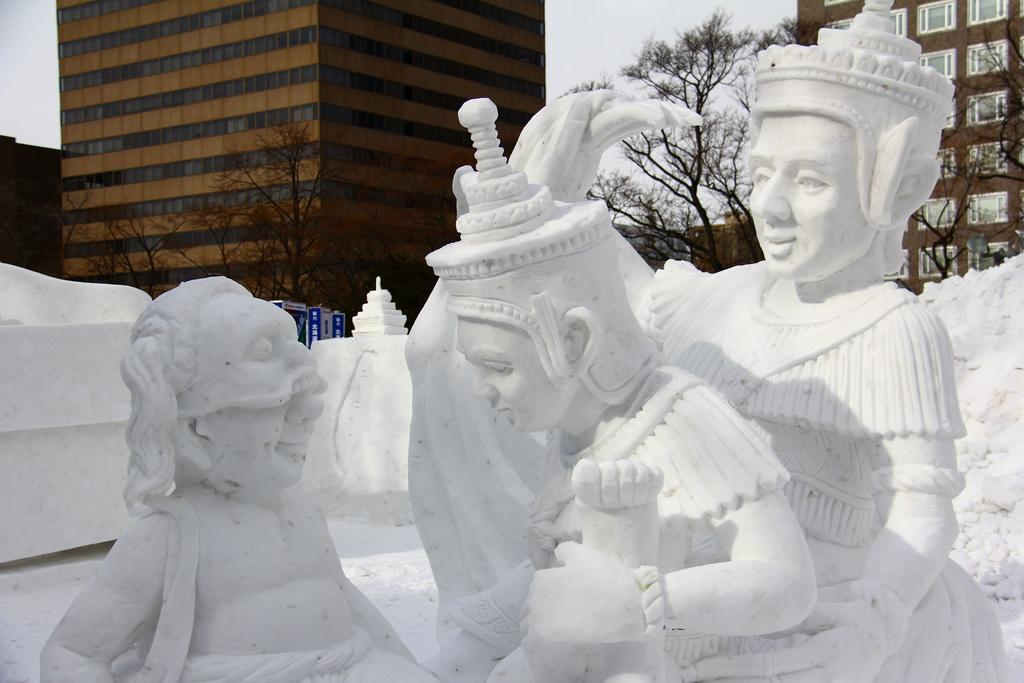What can be seen in the foreground of the image? There are sculptures in the foreground of the image. What is visible in the background of the image? There are buildings and trees in the background of the image. What is attached to the pole in the image? There are boards on a pole in the image. What is visible at the top of the image? The sky is visible at the top of the image. Can you tell me how many daughters are depicted in the scene? There is no scene or daughter present in the image; it features sculptures, buildings, trees, boards on a pole, and the sky. What type of cave can be seen in the background of the image? There is no cave present in the image; it features buildings and trees in the background. 